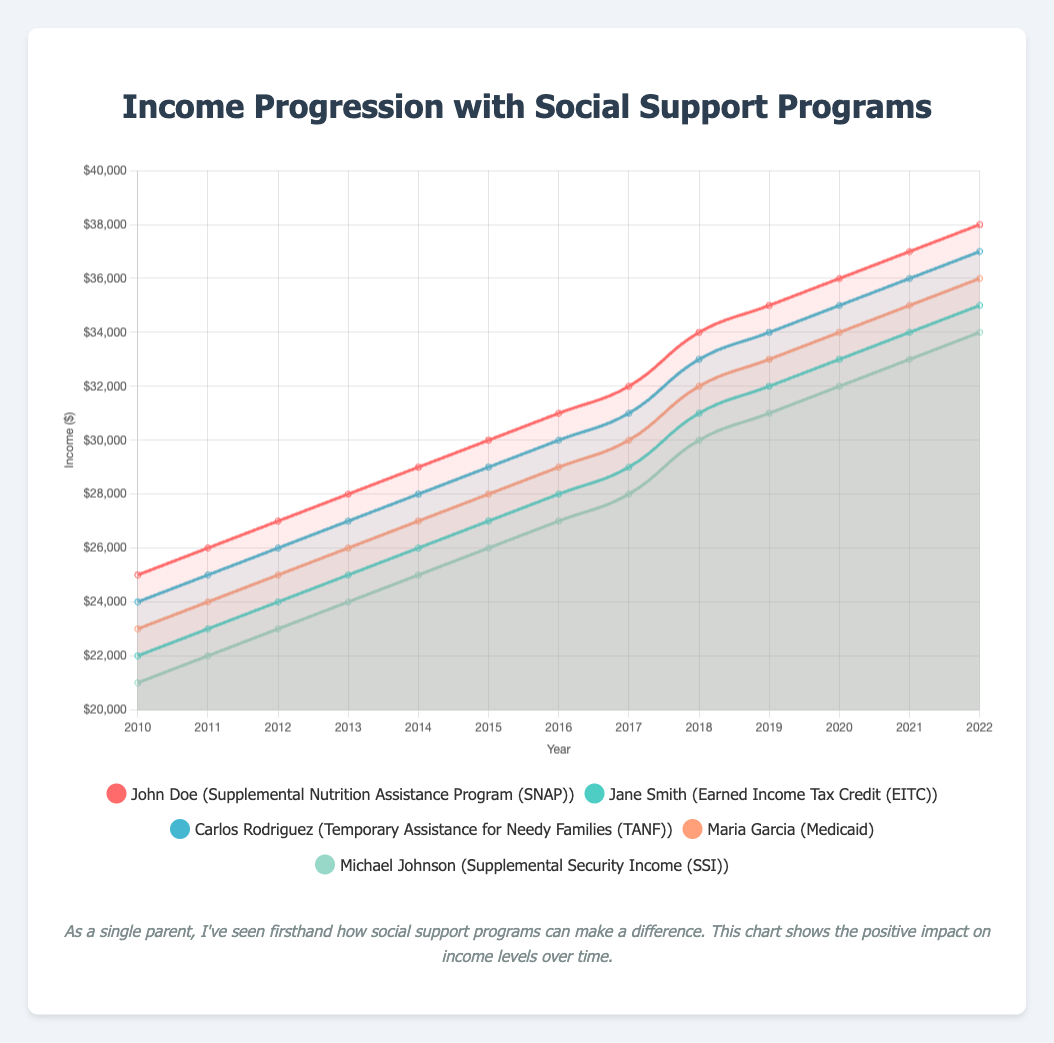What is the average income for Maria Garcia between 2012 and 2015? To find the average income between 2012 and 2015 for Maria Garcia, add the incomes for these years (25000, 26000, 27000, 28000) and then divide by the number of years (4). Calculation: (25000 + 26000 + 27000 + 28000) / 4 = 106000 / 4 = 26500
Answer: 26500 Who had the highest income in 2022? Compare the incomes of all individuals in 2022. John Doe had 38000, Jane Smith had 35000, Carlos Rodriguez had 37000, Maria Garcia had 36000, Michael Johnson had 34000. John Doe had the highest income in 2022.
Answer: John Doe What is the income difference between Carlos Rodriguez and Jane Smith in 2019? Look at their incomes in 2019: Carlos Rodriguez had 34000 and Jane Smith had 32000. Calculate the difference: 34000 - 32000 = 2000
Answer: 2000 Between John Doe and Michael Johnson, who had a greater increase in income from 2010 to 2022? Calculate the increase for each: John Doe (38000 - 25000 = 13000) and Michael Johnson (34000 - 21000 = 13000). Both individuals had the same increase in income.
Answer: Both had the same increase Who had the steadiest income increase over the years? Assess the income trends. Each individual’s income increases by 1000 units each year steadily. All individuals had a consistent annual income increase.
Answer: All individuals Which individual shows the steepest rise in income between 2016 and 2017? Compare the income differences for all individuals between 2016 and 2017. Each individual's income increased by 1000 except for this period. John Doe's income went from 31000 to 32000, Jane Smith's from 28000 to 29000, Carlos Rodriguez's from 30000 to 31000, Maria Garcia's from 29000 to 30000, and Michael Johnson's from 27000 to 28000. Hence, they all had an equal rise in income.
Answer: All individuals What is the total income for all individuals in 2017? Add the incomes for all individuals in that year. John Doe (32000), Jane Smith (29000), Carlos Rodriguez (31000), Maria Garcia (30000), Michael Johnson (28000). Calculation: 32000 + 29000 + 31000 + 30000 + 28000 = 150000
Answer: 150000 